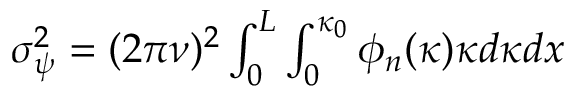Convert formula to latex. <formula><loc_0><loc_0><loc_500><loc_500>\begin{array} { r } { \sigma _ { \psi } ^ { 2 } = ( 2 { \pi } \nu ) ^ { 2 } \int _ { 0 } ^ { L } \int _ { 0 } ^ { \kappa _ { 0 } } \phi _ { n } ( \kappa ) { \kappa } d { \kappa } d x } \end{array}</formula> 